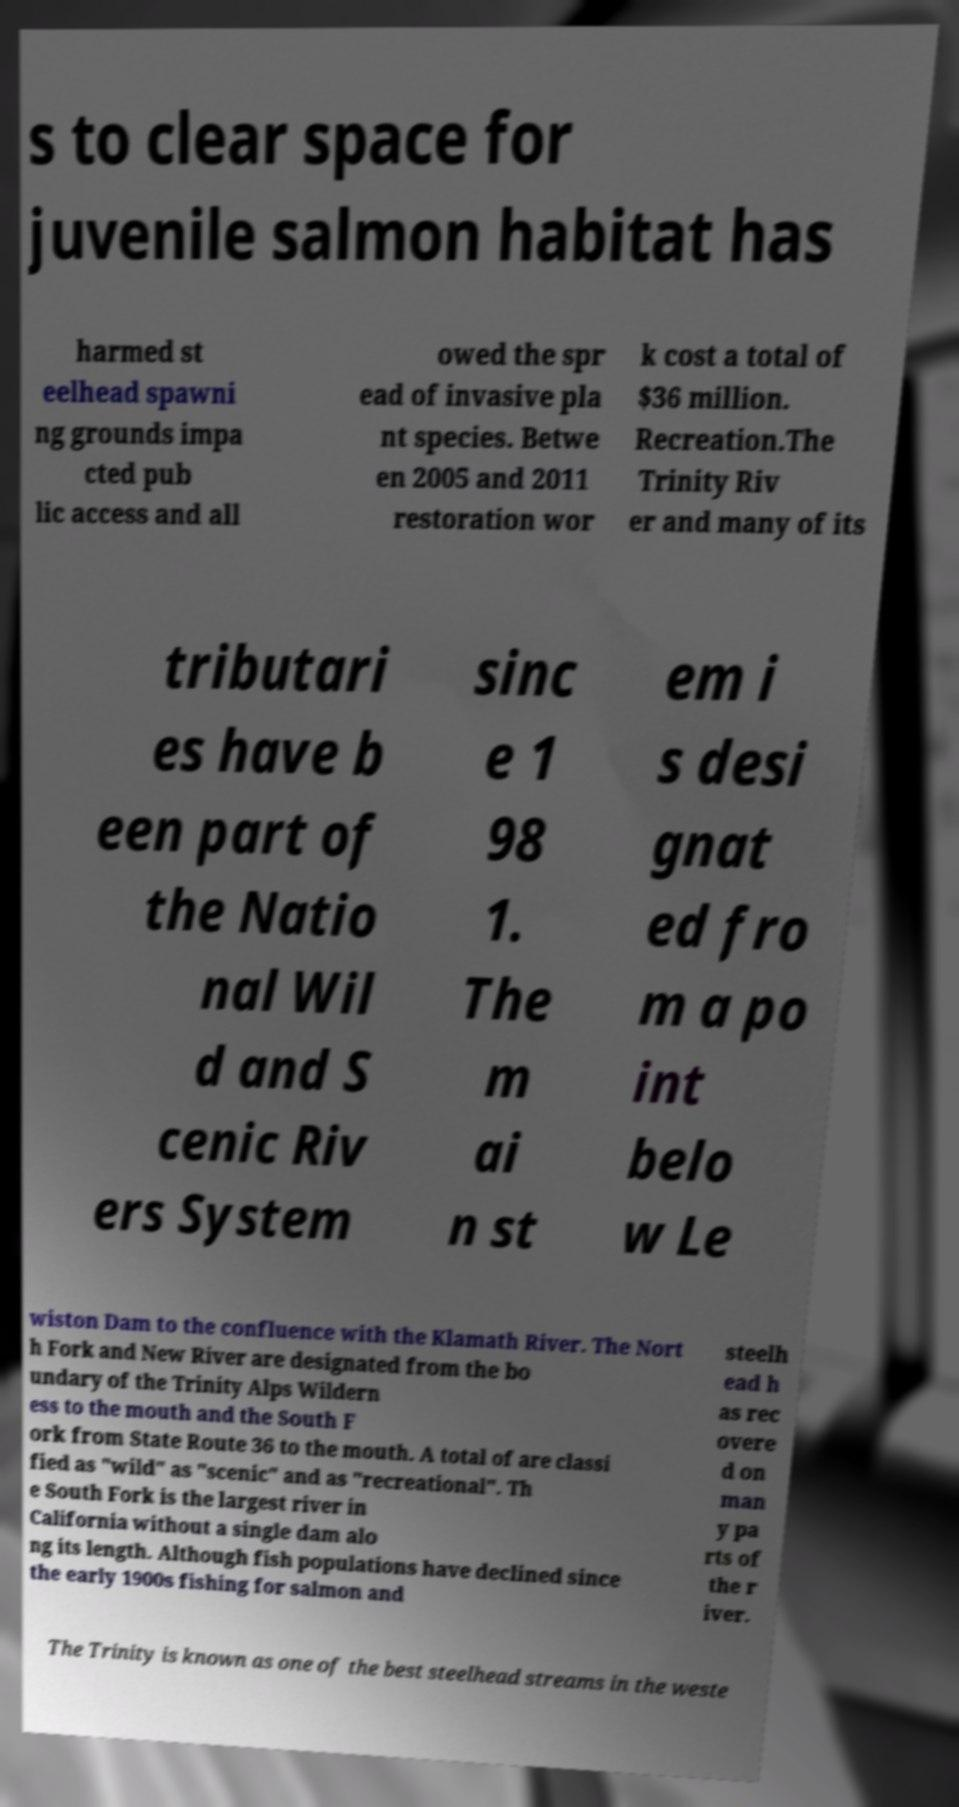For documentation purposes, I need the text within this image transcribed. Could you provide that? s to clear space for juvenile salmon habitat has harmed st eelhead spawni ng grounds impa cted pub lic access and all owed the spr ead of invasive pla nt species. Betwe en 2005 and 2011 restoration wor k cost a total of $36 million. Recreation.The Trinity Riv er and many of its tributari es have b een part of the Natio nal Wil d and S cenic Riv ers System sinc e 1 98 1. The m ai n st em i s desi gnat ed fro m a po int belo w Le wiston Dam to the confluence with the Klamath River. The Nort h Fork and New River are designated from the bo undary of the Trinity Alps Wildern ess to the mouth and the South F ork from State Route 36 to the mouth. A total of are classi fied as "wild" as "scenic" and as "recreational". Th e South Fork is the largest river in California without a single dam alo ng its length. Although fish populations have declined since the early 1900s fishing for salmon and steelh ead h as rec overe d on man y pa rts of the r iver. The Trinity is known as one of the best steelhead streams in the weste 